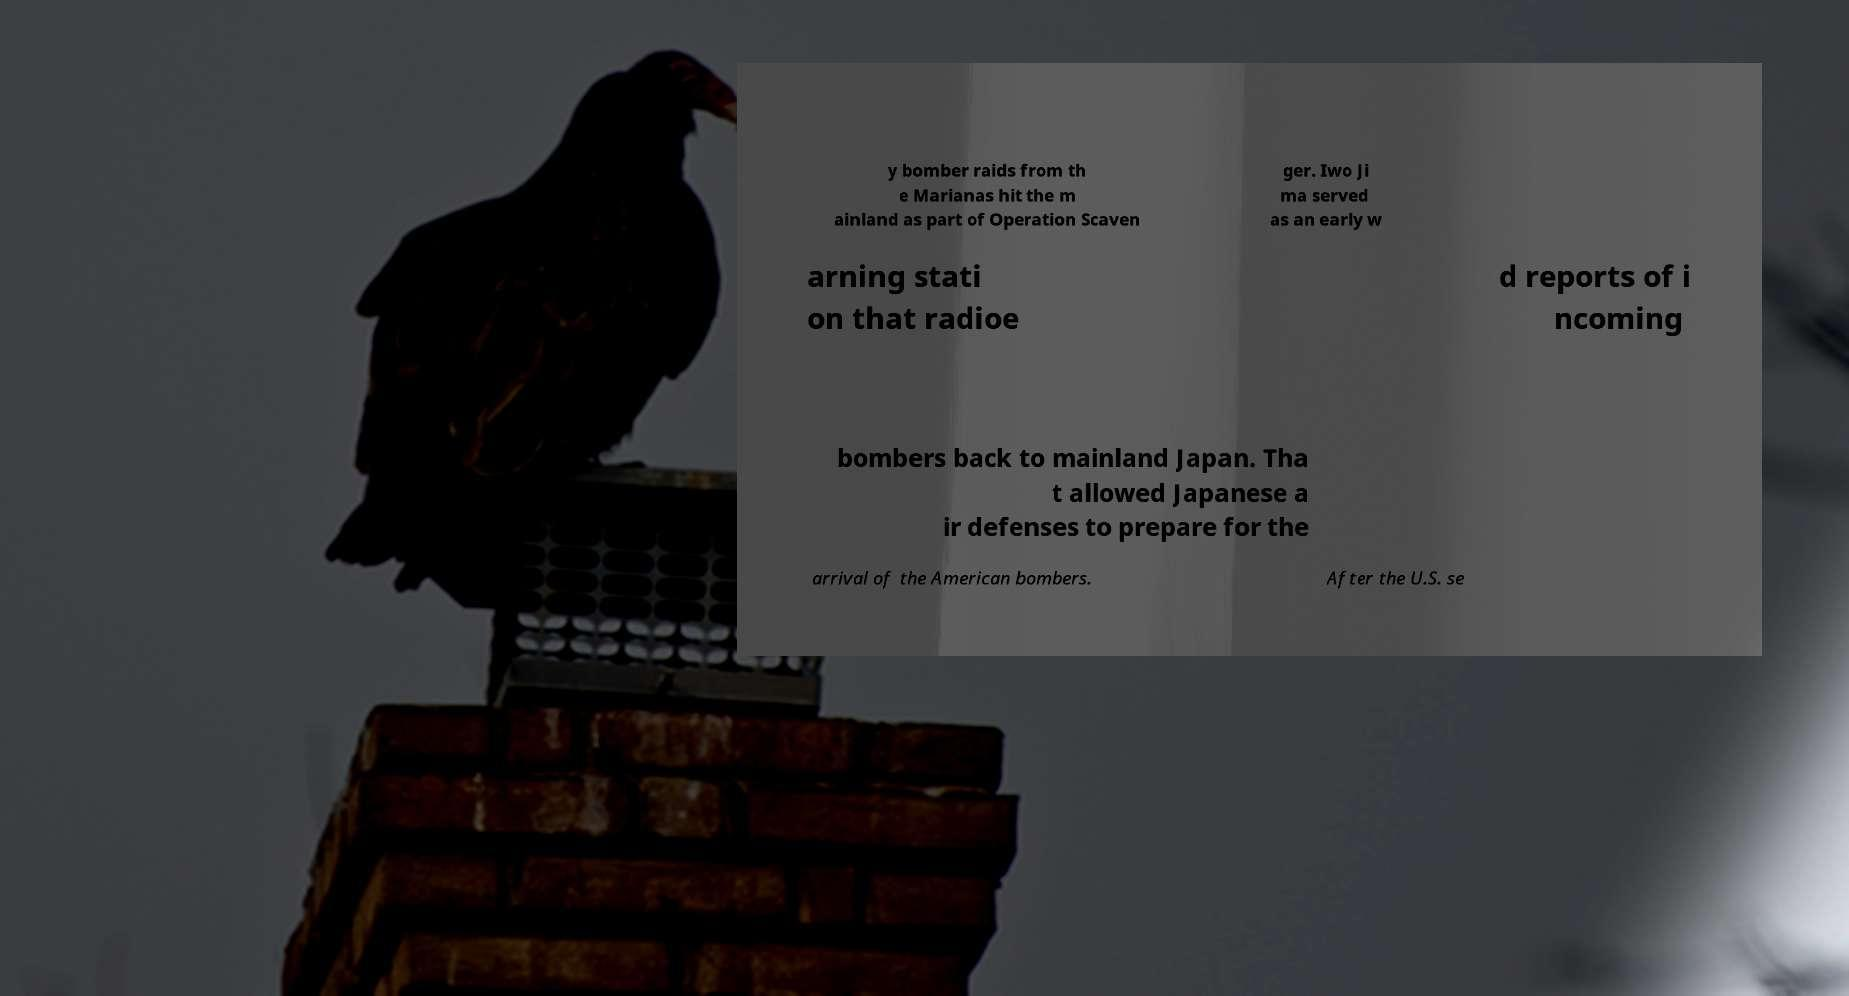What messages or text are displayed in this image? I need them in a readable, typed format. y bomber raids from th e Marianas hit the m ainland as part of Operation Scaven ger. Iwo Ji ma served as an early w arning stati on that radioe d reports of i ncoming bombers back to mainland Japan. Tha t allowed Japanese a ir defenses to prepare for the arrival of the American bombers. After the U.S. se 